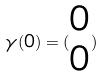Convert formula to latex. <formula><loc_0><loc_0><loc_500><loc_500>\gamma ( 0 ) = ( \begin{matrix} 0 \\ 0 \end{matrix} )</formula> 